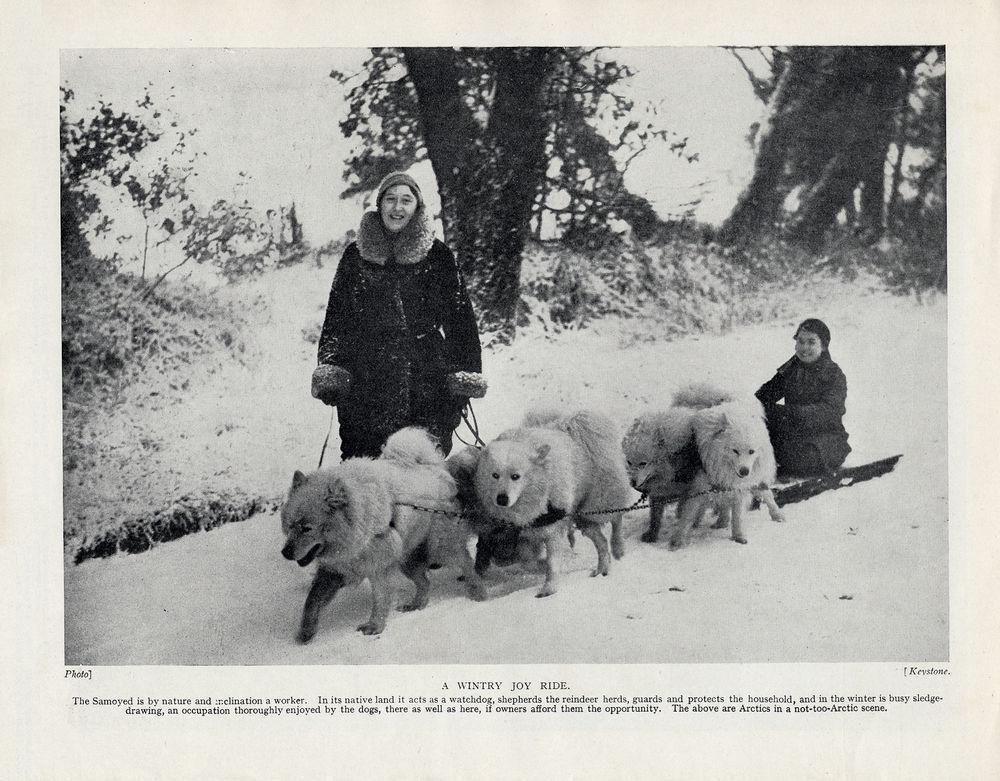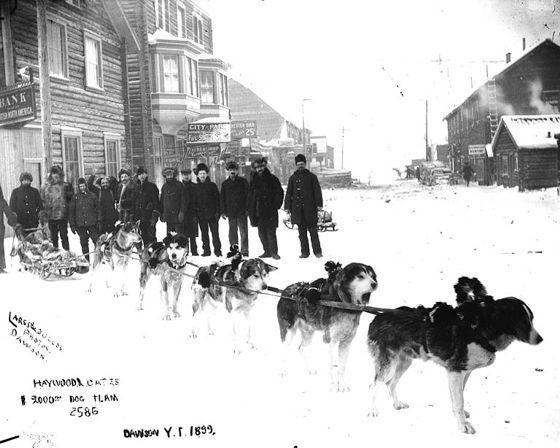The first image is the image on the left, the second image is the image on the right. Assess this claim about the two images: "There are fewer than four people in total.". Correct or not? Answer yes or no. No. The first image is the image on the left, the second image is the image on the right. Analyze the images presented: Is the assertion "Each image shows a dog team with a standing sled driver at the back in a snow-covered field with no business buildings in view." valid? Answer yes or no. No. 